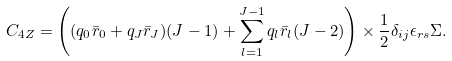<formula> <loc_0><loc_0><loc_500><loc_500>& C _ { 4 Z } = \left ( ( q _ { 0 } \bar { r } _ { 0 } + q _ { J } \bar { r } _ { J } ) ( J - 1 ) + \sum _ { l = 1 } ^ { J - 1 } q _ { l } \bar { r } _ { l } ( J - 2 ) \right ) \times \frac { 1 } { 2 } \delta _ { i j } \epsilon _ { r s } \Sigma .</formula> 